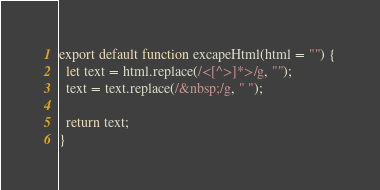Convert code to text. <code><loc_0><loc_0><loc_500><loc_500><_JavaScript_>export default function excapeHtml(html = "") {
  let text = html.replace(/<[^>]*>/g, "");
  text = text.replace(/&nbsp;/g, " ");

  return text;
}
</code> 